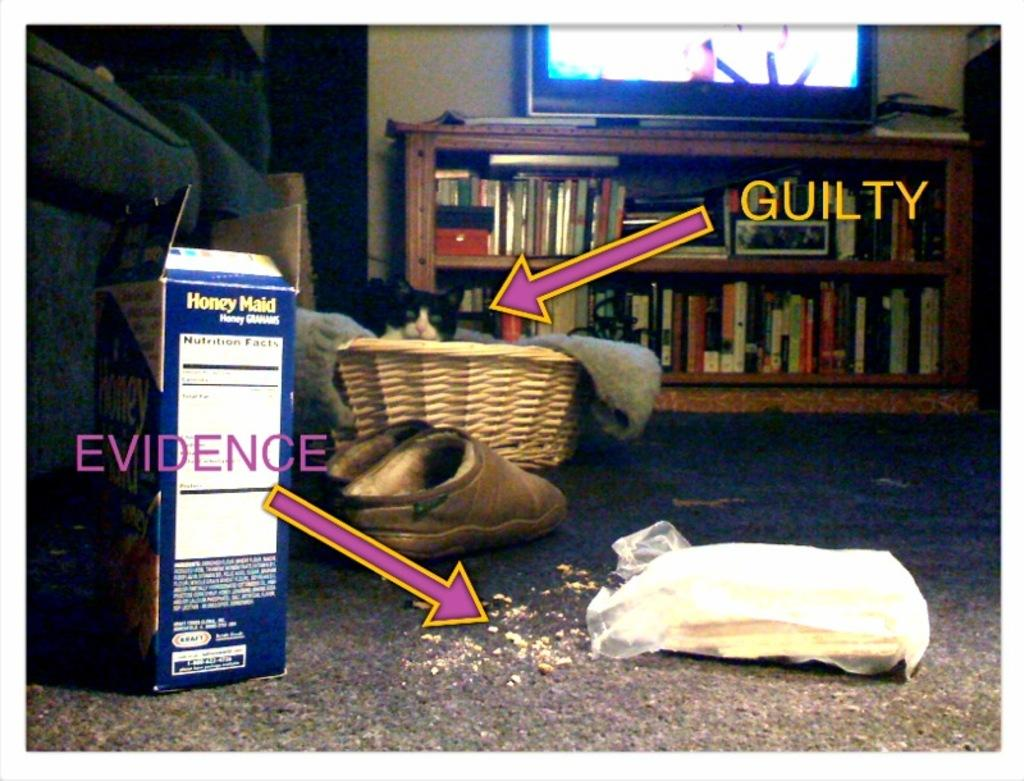<image>
Relay a brief, clear account of the picture shown. a picture with honey maid branded honey grahams with a cat in the background. 